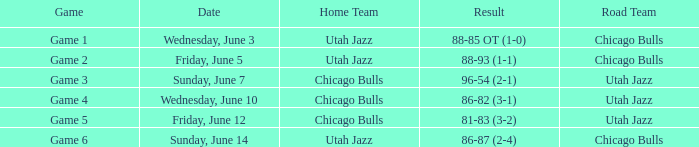What game has a score of 86-87 (2-4)? Game 6. 